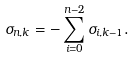<formula> <loc_0><loc_0><loc_500><loc_500>\sigma _ { n , k } = - \sum _ { i = 0 } ^ { n - 2 } \sigma _ { i , k - 1 } .</formula> 